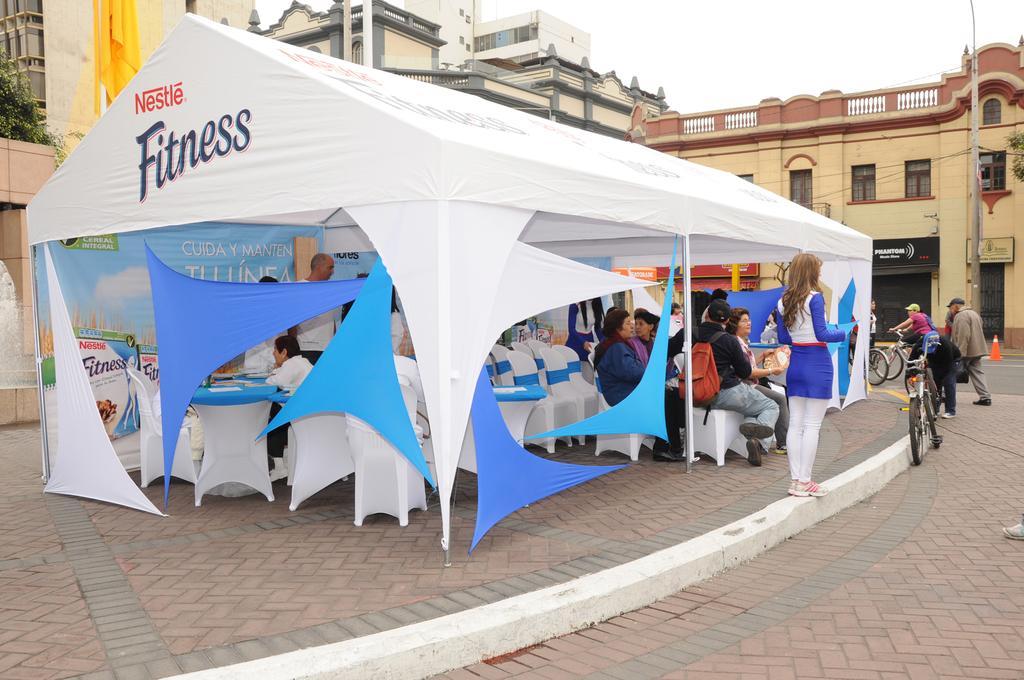Could you give a brief overview of what you see in this image? This image is clicked on the road. In the foreground there is a tent on the walkway. There are tables and chairs under the tent. There are people sitting on the chairs. Behind the text there are bicycles on the road. In the background there are buildings and trees. At the top there is the sky. To the right there is a pole. Beside the pole there is a cone barrier on the ground. 